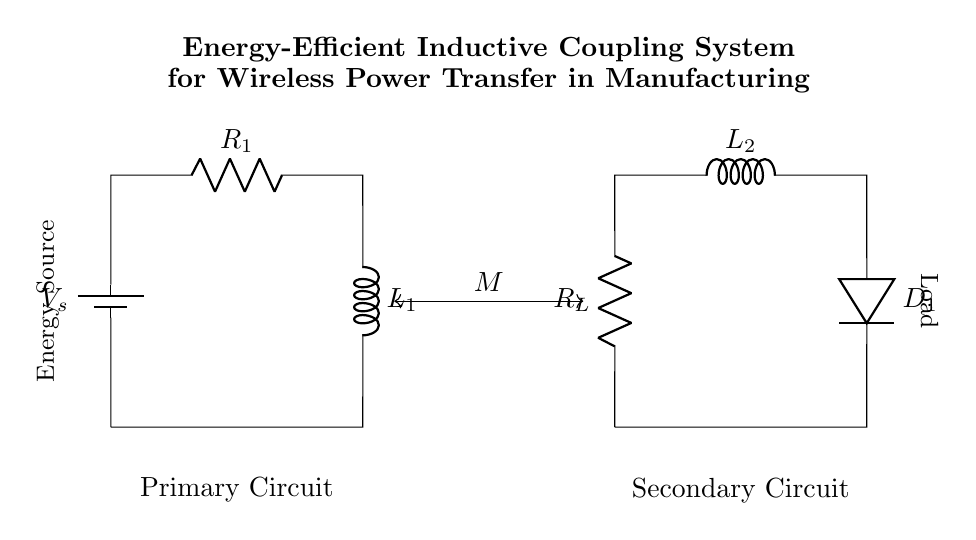What components are present in the primary circuit? The primary circuit contains a battery, a resistor, and an inductor. These components are specifically labeled in the diagram as V_s (battery), R_1 (resistor), and L_1 (inductor).
Answer: battery, resistor, inductor What is the load in the secondary circuit? The load in the secondary circuit is represented as R_L, which is labeled as a resistor in the diagram. This indicates the component that consumes energy in the circuit.
Answer: resistor What is the purpose of the coupling represented by M? The coupling M indicates the mutual inductance between the primary and secondary circuits. It allows for energy transfer via magnetic fields between the inductors L_1 and L_2 without a physical connection.
Answer: mutual inductance What is the voltage source represented as in the primary circuit? The voltage source in the primary circuit is denoted by V_s, which indicates the supply voltage provided to the circuit for operation.
Answer: V_s How many inductors are present in the circuit? There are two inductors, L_1 in the primary circuit and L_2 in the secondary circuit, as indicated in the diagram. Each is labeled clearly.
Answer: two What type of diodes are used in the secondary circuit? The diagram indicates a single diode labeled as D_1 in the secondary circuit, which is used for rectifying the AC voltage generated in the secondary inductor during operation.
Answer: D_1 What is the relationship between resistor R_1 and inductor L_1 in the primary circuit? The resistor R_1 and inductor L_1 in the primary circuit form an R-L series circuit, which affects the overall impedance and energy storage characteristics.
Answer: R-L series circuit 